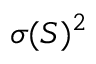<formula> <loc_0><loc_0><loc_500><loc_500>\sigma ( S ) ^ { 2 }</formula> 